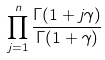<formula> <loc_0><loc_0><loc_500><loc_500>\prod _ { j = 1 } ^ { n } \frac { \Gamma ( 1 + j \gamma ) } { \Gamma ( 1 + \gamma ) }</formula> 